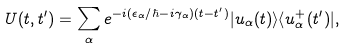<formula> <loc_0><loc_0><loc_500><loc_500>U ( t , t ^ { \prime } ) = \sum _ { \alpha } e ^ { - i ( \epsilon _ { \alpha } / \hbar { - } i \gamma _ { \alpha } ) ( t - t ^ { \prime } ) } | u _ { \alpha } ( t ) \rangle \langle u ^ { + } _ { \alpha } ( t ^ { \prime } ) | ,</formula> 